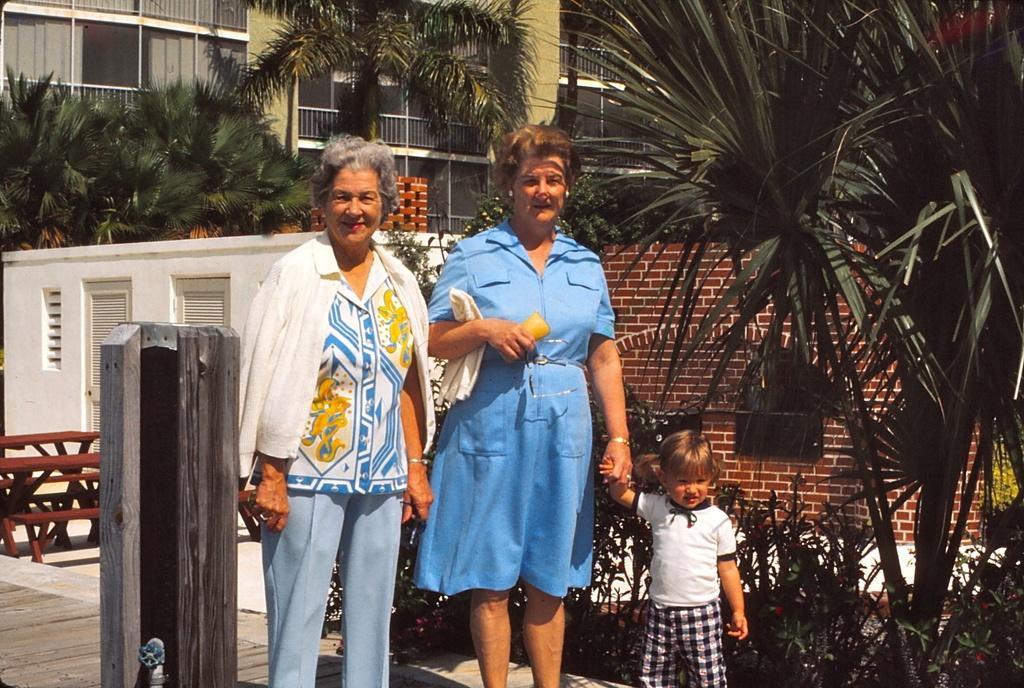Please provide a concise description of this image. In this image there are two women and a kid are standing on the path. Left side there is an object. Behind there are benches on the floor. Right side there are plants on the land. Background there are buildings and trees. 